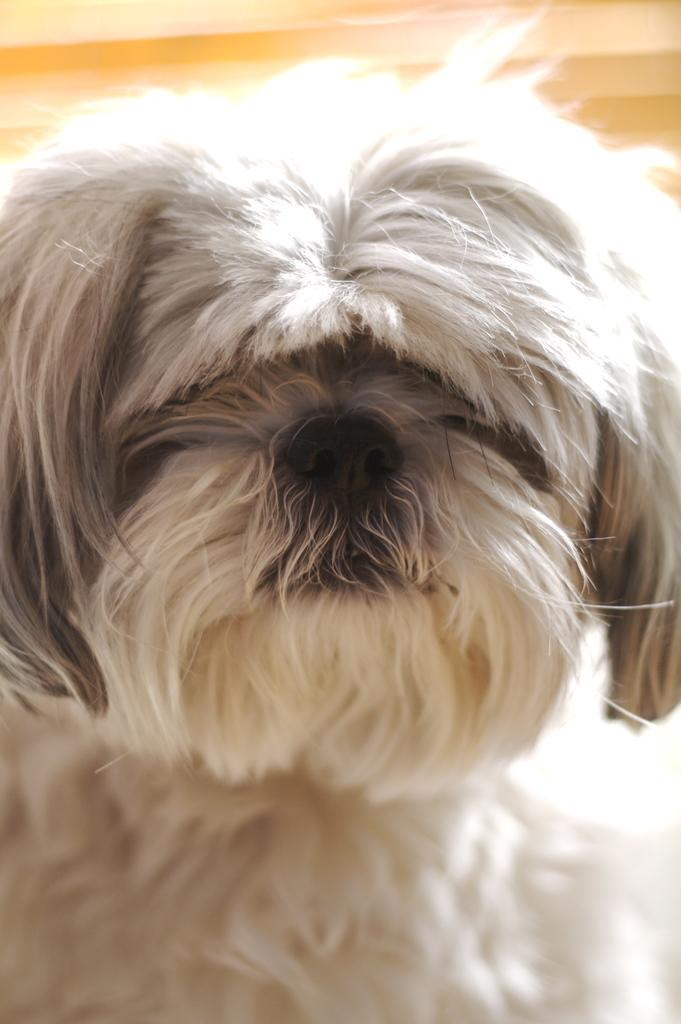What type of animal is present in the image? There is a white dog in the image. What type of prose can be seen in the image? There is no prose present in the image; it features a white dog. How many ducks are visible in the image? There are no ducks present in the image. 